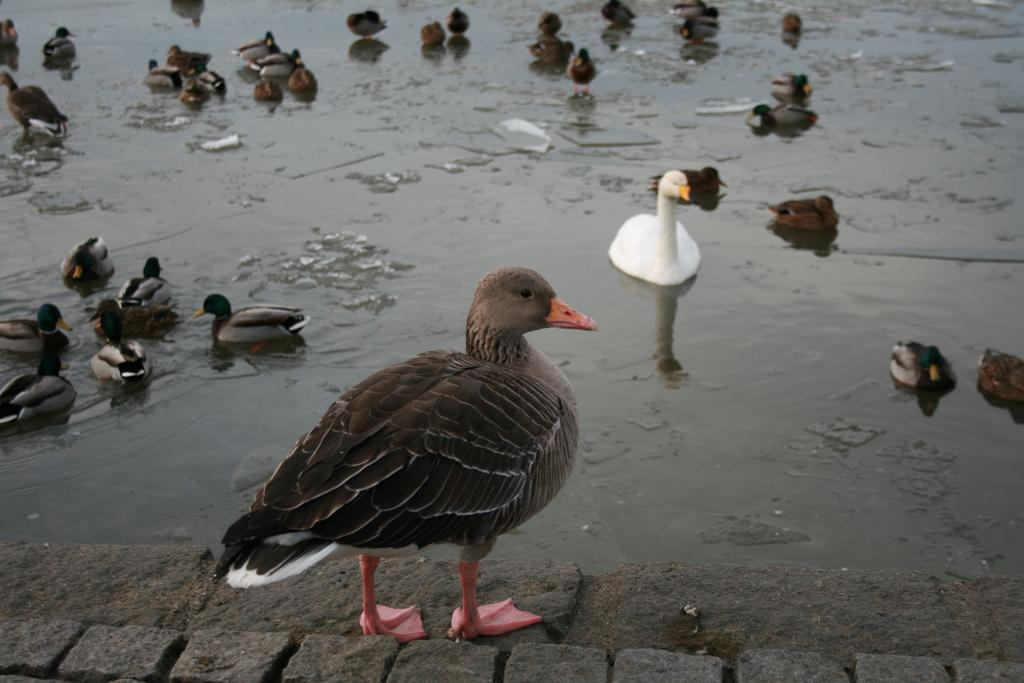What type of animals can be seen in the image? There are ducks and a swan in the image. Where are the ducks and swan located? The ducks and swan are on the water in the image. Is there any other duck in a different position in the image? Yes, there is a duck standing on the floor in the foreground of the image. What type of teeth can be seen on the ducks in the image? Ducks do not have teeth, so there are no teeth visible on the ducks in the image. 